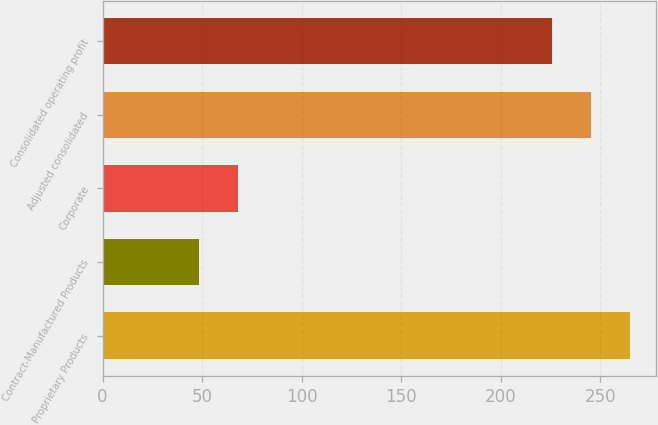Convert chart. <chart><loc_0><loc_0><loc_500><loc_500><bar_chart><fcel>Proprietary Products<fcel>Contract-Manufactured Products<fcel>Corporate<fcel>Adjusted consolidated<fcel>Consolidated operating profit<nl><fcel>264.9<fcel>48.3<fcel>67.85<fcel>245.35<fcel>225.8<nl></chart> 